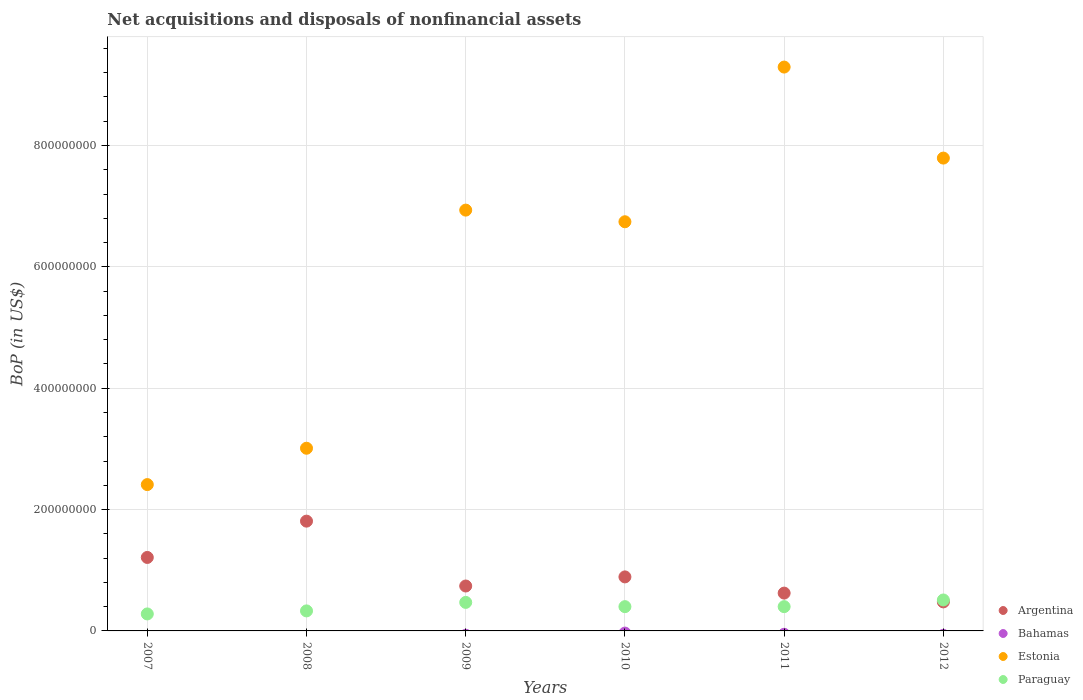How many different coloured dotlines are there?
Provide a short and direct response. 3. Is the number of dotlines equal to the number of legend labels?
Make the answer very short. No. What is the Balance of Payments in Bahamas in 2010?
Give a very brief answer. 0. Across all years, what is the maximum Balance of Payments in Estonia?
Make the answer very short. 9.29e+08. Across all years, what is the minimum Balance of Payments in Estonia?
Provide a succinct answer. 2.41e+08. In which year was the Balance of Payments in Estonia maximum?
Your answer should be very brief. 2011. What is the total Balance of Payments in Argentina in the graph?
Offer a very short reply. 5.75e+08. What is the difference between the Balance of Payments in Paraguay in 2008 and that in 2011?
Provide a short and direct response. -7.00e+06. What is the difference between the Balance of Payments in Estonia in 2011 and the Balance of Payments in Bahamas in 2008?
Ensure brevity in your answer.  9.29e+08. In the year 2011, what is the difference between the Balance of Payments in Estonia and Balance of Payments in Paraguay?
Provide a succinct answer. 8.89e+08. In how many years, is the Balance of Payments in Argentina greater than 440000000 US$?
Make the answer very short. 0. What is the ratio of the Balance of Payments in Estonia in 2007 to that in 2011?
Make the answer very short. 0.26. Is the Balance of Payments in Paraguay in 2007 less than that in 2010?
Provide a short and direct response. Yes. What is the difference between the highest and the second highest Balance of Payments in Argentina?
Keep it short and to the point. 5.98e+07. What is the difference between the highest and the lowest Balance of Payments in Argentina?
Offer a terse response. 1.33e+08. Is it the case that in every year, the sum of the Balance of Payments in Paraguay and Balance of Payments in Bahamas  is greater than the Balance of Payments in Argentina?
Give a very brief answer. No. Does the Balance of Payments in Argentina monotonically increase over the years?
Your answer should be very brief. No. How many dotlines are there?
Offer a terse response. 3. How many years are there in the graph?
Keep it short and to the point. 6. What is the difference between two consecutive major ticks on the Y-axis?
Make the answer very short. 2.00e+08. Does the graph contain grids?
Provide a succinct answer. Yes. Where does the legend appear in the graph?
Offer a terse response. Bottom right. How many legend labels are there?
Give a very brief answer. 4. How are the legend labels stacked?
Provide a succinct answer. Vertical. What is the title of the graph?
Ensure brevity in your answer.  Net acquisitions and disposals of nonfinancial assets. What is the label or title of the X-axis?
Ensure brevity in your answer.  Years. What is the label or title of the Y-axis?
Keep it short and to the point. BoP (in US$). What is the BoP (in US$) in Argentina in 2007?
Your answer should be very brief. 1.21e+08. What is the BoP (in US$) of Estonia in 2007?
Offer a very short reply. 2.41e+08. What is the BoP (in US$) in Paraguay in 2007?
Offer a terse response. 2.80e+07. What is the BoP (in US$) in Argentina in 2008?
Offer a very short reply. 1.81e+08. What is the BoP (in US$) of Estonia in 2008?
Offer a very short reply. 3.01e+08. What is the BoP (in US$) of Paraguay in 2008?
Keep it short and to the point. 3.30e+07. What is the BoP (in US$) in Argentina in 2009?
Your answer should be compact. 7.40e+07. What is the BoP (in US$) in Estonia in 2009?
Your answer should be very brief. 6.94e+08. What is the BoP (in US$) in Paraguay in 2009?
Make the answer very short. 4.70e+07. What is the BoP (in US$) in Argentina in 2010?
Provide a succinct answer. 8.90e+07. What is the BoP (in US$) of Estonia in 2010?
Your answer should be compact. 6.74e+08. What is the BoP (in US$) of Paraguay in 2010?
Make the answer very short. 4.00e+07. What is the BoP (in US$) in Argentina in 2011?
Give a very brief answer. 6.23e+07. What is the BoP (in US$) of Bahamas in 2011?
Offer a very short reply. 0. What is the BoP (in US$) in Estonia in 2011?
Offer a very short reply. 9.29e+08. What is the BoP (in US$) in Paraguay in 2011?
Your answer should be very brief. 4.00e+07. What is the BoP (in US$) of Argentina in 2012?
Offer a terse response. 4.78e+07. What is the BoP (in US$) in Estonia in 2012?
Your answer should be very brief. 7.79e+08. What is the BoP (in US$) in Paraguay in 2012?
Your response must be concise. 5.10e+07. Across all years, what is the maximum BoP (in US$) of Argentina?
Offer a terse response. 1.81e+08. Across all years, what is the maximum BoP (in US$) of Estonia?
Your answer should be compact. 9.29e+08. Across all years, what is the maximum BoP (in US$) of Paraguay?
Your answer should be compact. 5.10e+07. Across all years, what is the minimum BoP (in US$) in Argentina?
Keep it short and to the point. 4.78e+07. Across all years, what is the minimum BoP (in US$) in Estonia?
Make the answer very short. 2.41e+08. Across all years, what is the minimum BoP (in US$) of Paraguay?
Give a very brief answer. 2.80e+07. What is the total BoP (in US$) in Argentina in the graph?
Your response must be concise. 5.75e+08. What is the total BoP (in US$) of Estonia in the graph?
Your answer should be compact. 3.62e+09. What is the total BoP (in US$) in Paraguay in the graph?
Provide a short and direct response. 2.39e+08. What is the difference between the BoP (in US$) in Argentina in 2007 and that in 2008?
Offer a terse response. -5.98e+07. What is the difference between the BoP (in US$) in Estonia in 2007 and that in 2008?
Provide a short and direct response. -5.99e+07. What is the difference between the BoP (in US$) of Paraguay in 2007 and that in 2008?
Your response must be concise. -5.00e+06. What is the difference between the BoP (in US$) of Argentina in 2007 and that in 2009?
Provide a succinct answer. 4.71e+07. What is the difference between the BoP (in US$) of Estonia in 2007 and that in 2009?
Provide a succinct answer. -4.52e+08. What is the difference between the BoP (in US$) of Paraguay in 2007 and that in 2009?
Offer a terse response. -1.90e+07. What is the difference between the BoP (in US$) in Argentina in 2007 and that in 2010?
Ensure brevity in your answer.  3.21e+07. What is the difference between the BoP (in US$) of Estonia in 2007 and that in 2010?
Give a very brief answer. -4.33e+08. What is the difference between the BoP (in US$) of Paraguay in 2007 and that in 2010?
Offer a terse response. -1.20e+07. What is the difference between the BoP (in US$) of Argentina in 2007 and that in 2011?
Your answer should be very brief. 5.88e+07. What is the difference between the BoP (in US$) of Estonia in 2007 and that in 2011?
Ensure brevity in your answer.  -6.88e+08. What is the difference between the BoP (in US$) in Paraguay in 2007 and that in 2011?
Ensure brevity in your answer.  -1.20e+07. What is the difference between the BoP (in US$) of Argentina in 2007 and that in 2012?
Your response must be concise. 7.33e+07. What is the difference between the BoP (in US$) in Estonia in 2007 and that in 2012?
Offer a terse response. -5.38e+08. What is the difference between the BoP (in US$) of Paraguay in 2007 and that in 2012?
Your response must be concise. -2.30e+07. What is the difference between the BoP (in US$) of Argentina in 2008 and that in 2009?
Ensure brevity in your answer.  1.07e+08. What is the difference between the BoP (in US$) in Estonia in 2008 and that in 2009?
Offer a terse response. -3.92e+08. What is the difference between the BoP (in US$) in Paraguay in 2008 and that in 2009?
Offer a terse response. -1.40e+07. What is the difference between the BoP (in US$) of Argentina in 2008 and that in 2010?
Give a very brief answer. 9.19e+07. What is the difference between the BoP (in US$) of Estonia in 2008 and that in 2010?
Offer a very short reply. -3.73e+08. What is the difference between the BoP (in US$) of Paraguay in 2008 and that in 2010?
Offer a very short reply. -7.00e+06. What is the difference between the BoP (in US$) of Argentina in 2008 and that in 2011?
Keep it short and to the point. 1.19e+08. What is the difference between the BoP (in US$) of Estonia in 2008 and that in 2011?
Offer a very short reply. -6.28e+08. What is the difference between the BoP (in US$) of Paraguay in 2008 and that in 2011?
Make the answer very short. -7.00e+06. What is the difference between the BoP (in US$) of Argentina in 2008 and that in 2012?
Offer a very short reply. 1.33e+08. What is the difference between the BoP (in US$) in Estonia in 2008 and that in 2012?
Your answer should be very brief. -4.78e+08. What is the difference between the BoP (in US$) of Paraguay in 2008 and that in 2012?
Offer a terse response. -1.80e+07. What is the difference between the BoP (in US$) of Argentina in 2009 and that in 2010?
Keep it short and to the point. -1.50e+07. What is the difference between the BoP (in US$) in Estonia in 2009 and that in 2010?
Your response must be concise. 1.92e+07. What is the difference between the BoP (in US$) of Paraguay in 2009 and that in 2010?
Offer a very short reply. 7.00e+06. What is the difference between the BoP (in US$) in Argentina in 2009 and that in 2011?
Your response must be concise. 1.17e+07. What is the difference between the BoP (in US$) in Estonia in 2009 and that in 2011?
Make the answer very short. -2.36e+08. What is the difference between the BoP (in US$) of Paraguay in 2009 and that in 2011?
Offer a very short reply. 7.00e+06. What is the difference between the BoP (in US$) of Argentina in 2009 and that in 2012?
Provide a succinct answer. 2.62e+07. What is the difference between the BoP (in US$) in Estonia in 2009 and that in 2012?
Give a very brief answer. -8.58e+07. What is the difference between the BoP (in US$) in Paraguay in 2009 and that in 2012?
Make the answer very short. -4.00e+06. What is the difference between the BoP (in US$) of Argentina in 2010 and that in 2011?
Make the answer very short. 2.67e+07. What is the difference between the BoP (in US$) of Estonia in 2010 and that in 2011?
Keep it short and to the point. -2.55e+08. What is the difference between the BoP (in US$) in Paraguay in 2010 and that in 2011?
Provide a succinct answer. 0. What is the difference between the BoP (in US$) of Argentina in 2010 and that in 2012?
Your answer should be very brief. 4.12e+07. What is the difference between the BoP (in US$) in Estonia in 2010 and that in 2012?
Ensure brevity in your answer.  -1.05e+08. What is the difference between the BoP (in US$) in Paraguay in 2010 and that in 2012?
Your response must be concise. -1.10e+07. What is the difference between the BoP (in US$) of Argentina in 2011 and that in 2012?
Your answer should be very brief. 1.45e+07. What is the difference between the BoP (in US$) in Estonia in 2011 and that in 2012?
Make the answer very short. 1.50e+08. What is the difference between the BoP (in US$) in Paraguay in 2011 and that in 2012?
Your response must be concise. -1.10e+07. What is the difference between the BoP (in US$) of Argentina in 2007 and the BoP (in US$) of Estonia in 2008?
Make the answer very short. -1.80e+08. What is the difference between the BoP (in US$) of Argentina in 2007 and the BoP (in US$) of Paraguay in 2008?
Provide a succinct answer. 8.81e+07. What is the difference between the BoP (in US$) of Estonia in 2007 and the BoP (in US$) of Paraguay in 2008?
Your answer should be very brief. 2.08e+08. What is the difference between the BoP (in US$) in Argentina in 2007 and the BoP (in US$) in Estonia in 2009?
Your response must be concise. -5.72e+08. What is the difference between the BoP (in US$) in Argentina in 2007 and the BoP (in US$) in Paraguay in 2009?
Keep it short and to the point. 7.41e+07. What is the difference between the BoP (in US$) of Estonia in 2007 and the BoP (in US$) of Paraguay in 2009?
Your response must be concise. 1.94e+08. What is the difference between the BoP (in US$) in Argentina in 2007 and the BoP (in US$) in Estonia in 2010?
Offer a very short reply. -5.53e+08. What is the difference between the BoP (in US$) of Argentina in 2007 and the BoP (in US$) of Paraguay in 2010?
Ensure brevity in your answer.  8.11e+07. What is the difference between the BoP (in US$) of Estonia in 2007 and the BoP (in US$) of Paraguay in 2010?
Provide a short and direct response. 2.01e+08. What is the difference between the BoP (in US$) in Argentina in 2007 and the BoP (in US$) in Estonia in 2011?
Ensure brevity in your answer.  -8.08e+08. What is the difference between the BoP (in US$) of Argentina in 2007 and the BoP (in US$) of Paraguay in 2011?
Your answer should be very brief. 8.11e+07. What is the difference between the BoP (in US$) in Estonia in 2007 and the BoP (in US$) in Paraguay in 2011?
Your response must be concise. 2.01e+08. What is the difference between the BoP (in US$) in Argentina in 2007 and the BoP (in US$) in Estonia in 2012?
Provide a succinct answer. -6.58e+08. What is the difference between the BoP (in US$) in Argentina in 2007 and the BoP (in US$) in Paraguay in 2012?
Offer a very short reply. 7.01e+07. What is the difference between the BoP (in US$) of Estonia in 2007 and the BoP (in US$) of Paraguay in 2012?
Keep it short and to the point. 1.90e+08. What is the difference between the BoP (in US$) in Argentina in 2008 and the BoP (in US$) in Estonia in 2009?
Provide a succinct answer. -5.13e+08. What is the difference between the BoP (in US$) of Argentina in 2008 and the BoP (in US$) of Paraguay in 2009?
Offer a terse response. 1.34e+08. What is the difference between the BoP (in US$) of Estonia in 2008 and the BoP (in US$) of Paraguay in 2009?
Provide a succinct answer. 2.54e+08. What is the difference between the BoP (in US$) of Argentina in 2008 and the BoP (in US$) of Estonia in 2010?
Your answer should be compact. -4.93e+08. What is the difference between the BoP (in US$) in Argentina in 2008 and the BoP (in US$) in Paraguay in 2010?
Give a very brief answer. 1.41e+08. What is the difference between the BoP (in US$) in Estonia in 2008 and the BoP (in US$) in Paraguay in 2010?
Offer a terse response. 2.61e+08. What is the difference between the BoP (in US$) of Argentina in 2008 and the BoP (in US$) of Estonia in 2011?
Give a very brief answer. -7.48e+08. What is the difference between the BoP (in US$) in Argentina in 2008 and the BoP (in US$) in Paraguay in 2011?
Give a very brief answer. 1.41e+08. What is the difference between the BoP (in US$) of Estonia in 2008 and the BoP (in US$) of Paraguay in 2011?
Ensure brevity in your answer.  2.61e+08. What is the difference between the BoP (in US$) of Argentina in 2008 and the BoP (in US$) of Estonia in 2012?
Offer a terse response. -5.98e+08. What is the difference between the BoP (in US$) of Argentina in 2008 and the BoP (in US$) of Paraguay in 2012?
Provide a succinct answer. 1.30e+08. What is the difference between the BoP (in US$) in Estonia in 2008 and the BoP (in US$) in Paraguay in 2012?
Your answer should be very brief. 2.50e+08. What is the difference between the BoP (in US$) of Argentina in 2009 and the BoP (in US$) of Estonia in 2010?
Keep it short and to the point. -6.00e+08. What is the difference between the BoP (in US$) of Argentina in 2009 and the BoP (in US$) of Paraguay in 2010?
Keep it short and to the point. 3.40e+07. What is the difference between the BoP (in US$) of Estonia in 2009 and the BoP (in US$) of Paraguay in 2010?
Provide a succinct answer. 6.54e+08. What is the difference between the BoP (in US$) in Argentina in 2009 and the BoP (in US$) in Estonia in 2011?
Offer a very short reply. -8.55e+08. What is the difference between the BoP (in US$) in Argentina in 2009 and the BoP (in US$) in Paraguay in 2011?
Your response must be concise. 3.40e+07. What is the difference between the BoP (in US$) in Estonia in 2009 and the BoP (in US$) in Paraguay in 2011?
Your answer should be very brief. 6.54e+08. What is the difference between the BoP (in US$) in Argentina in 2009 and the BoP (in US$) in Estonia in 2012?
Your answer should be compact. -7.05e+08. What is the difference between the BoP (in US$) in Argentina in 2009 and the BoP (in US$) in Paraguay in 2012?
Provide a short and direct response. 2.30e+07. What is the difference between the BoP (in US$) of Estonia in 2009 and the BoP (in US$) of Paraguay in 2012?
Make the answer very short. 6.43e+08. What is the difference between the BoP (in US$) of Argentina in 2010 and the BoP (in US$) of Estonia in 2011?
Your response must be concise. -8.40e+08. What is the difference between the BoP (in US$) of Argentina in 2010 and the BoP (in US$) of Paraguay in 2011?
Provide a succinct answer. 4.90e+07. What is the difference between the BoP (in US$) in Estonia in 2010 and the BoP (in US$) in Paraguay in 2011?
Provide a succinct answer. 6.34e+08. What is the difference between the BoP (in US$) of Argentina in 2010 and the BoP (in US$) of Estonia in 2012?
Ensure brevity in your answer.  -6.90e+08. What is the difference between the BoP (in US$) in Argentina in 2010 and the BoP (in US$) in Paraguay in 2012?
Offer a terse response. 3.80e+07. What is the difference between the BoP (in US$) of Estonia in 2010 and the BoP (in US$) of Paraguay in 2012?
Your answer should be compact. 6.23e+08. What is the difference between the BoP (in US$) in Argentina in 2011 and the BoP (in US$) in Estonia in 2012?
Your response must be concise. -7.17e+08. What is the difference between the BoP (in US$) of Argentina in 2011 and the BoP (in US$) of Paraguay in 2012?
Your response must be concise. 1.13e+07. What is the difference between the BoP (in US$) in Estonia in 2011 and the BoP (in US$) in Paraguay in 2012?
Ensure brevity in your answer.  8.78e+08. What is the average BoP (in US$) in Argentina per year?
Provide a short and direct response. 9.59e+07. What is the average BoP (in US$) of Bahamas per year?
Your response must be concise. 0. What is the average BoP (in US$) of Estonia per year?
Your answer should be compact. 6.03e+08. What is the average BoP (in US$) of Paraguay per year?
Make the answer very short. 3.98e+07. In the year 2007, what is the difference between the BoP (in US$) in Argentina and BoP (in US$) in Estonia?
Make the answer very short. -1.20e+08. In the year 2007, what is the difference between the BoP (in US$) in Argentina and BoP (in US$) in Paraguay?
Provide a succinct answer. 9.31e+07. In the year 2007, what is the difference between the BoP (in US$) of Estonia and BoP (in US$) of Paraguay?
Your response must be concise. 2.13e+08. In the year 2008, what is the difference between the BoP (in US$) in Argentina and BoP (in US$) in Estonia?
Your response must be concise. -1.20e+08. In the year 2008, what is the difference between the BoP (in US$) of Argentina and BoP (in US$) of Paraguay?
Provide a short and direct response. 1.48e+08. In the year 2008, what is the difference between the BoP (in US$) of Estonia and BoP (in US$) of Paraguay?
Offer a terse response. 2.68e+08. In the year 2009, what is the difference between the BoP (in US$) in Argentina and BoP (in US$) in Estonia?
Provide a succinct answer. -6.19e+08. In the year 2009, what is the difference between the BoP (in US$) in Argentina and BoP (in US$) in Paraguay?
Your response must be concise. 2.70e+07. In the year 2009, what is the difference between the BoP (in US$) of Estonia and BoP (in US$) of Paraguay?
Your answer should be very brief. 6.47e+08. In the year 2010, what is the difference between the BoP (in US$) in Argentina and BoP (in US$) in Estonia?
Keep it short and to the point. -5.85e+08. In the year 2010, what is the difference between the BoP (in US$) of Argentina and BoP (in US$) of Paraguay?
Ensure brevity in your answer.  4.90e+07. In the year 2010, what is the difference between the BoP (in US$) in Estonia and BoP (in US$) in Paraguay?
Your answer should be very brief. 6.34e+08. In the year 2011, what is the difference between the BoP (in US$) in Argentina and BoP (in US$) in Estonia?
Your answer should be compact. -8.67e+08. In the year 2011, what is the difference between the BoP (in US$) of Argentina and BoP (in US$) of Paraguay?
Provide a succinct answer. 2.23e+07. In the year 2011, what is the difference between the BoP (in US$) of Estonia and BoP (in US$) of Paraguay?
Your answer should be very brief. 8.89e+08. In the year 2012, what is the difference between the BoP (in US$) of Argentina and BoP (in US$) of Estonia?
Your answer should be compact. -7.31e+08. In the year 2012, what is the difference between the BoP (in US$) in Argentina and BoP (in US$) in Paraguay?
Offer a terse response. -3.16e+06. In the year 2012, what is the difference between the BoP (in US$) of Estonia and BoP (in US$) of Paraguay?
Keep it short and to the point. 7.28e+08. What is the ratio of the BoP (in US$) of Argentina in 2007 to that in 2008?
Make the answer very short. 0.67. What is the ratio of the BoP (in US$) of Estonia in 2007 to that in 2008?
Give a very brief answer. 0.8. What is the ratio of the BoP (in US$) in Paraguay in 2007 to that in 2008?
Give a very brief answer. 0.85. What is the ratio of the BoP (in US$) of Argentina in 2007 to that in 2009?
Provide a short and direct response. 1.64. What is the ratio of the BoP (in US$) of Estonia in 2007 to that in 2009?
Provide a succinct answer. 0.35. What is the ratio of the BoP (in US$) of Paraguay in 2007 to that in 2009?
Your answer should be very brief. 0.6. What is the ratio of the BoP (in US$) in Argentina in 2007 to that in 2010?
Keep it short and to the point. 1.36. What is the ratio of the BoP (in US$) in Estonia in 2007 to that in 2010?
Ensure brevity in your answer.  0.36. What is the ratio of the BoP (in US$) in Argentina in 2007 to that in 2011?
Your response must be concise. 1.94. What is the ratio of the BoP (in US$) of Estonia in 2007 to that in 2011?
Provide a short and direct response. 0.26. What is the ratio of the BoP (in US$) in Paraguay in 2007 to that in 2011?
Your response must be concise. 0.7. What is the ratio of the BoP (in US$) of Argentina in 2007 to that in 2012?
Your answer should be very brief. 2.53. What is the ratio of the BoP (in US$) of Estonia in 2007 to that in 2012?
Make the answer very short. 0.31. What is the ratio of the BoP (in US$) in Paraguay in 2007 to that in 2012?
Your answer should be compact. 0.55. What is the ratio of the BoP (in US$) of Argentina in 2008 to that in 2009?
Offer a very short reply. 2.44. What is the ratio of the BoP (in US$) in Estonia in 2008 to that in 2009?
Keep it short and to the point. 0.43. What is the ratio of the BoP (in US$) of Paraguay in 2008 to that in 2009?
Give a very brief answer. 0.7. What is the ratio of the BoP (in US$) in Argentina in 2008 to that in 2010?
Give a very brief answer. 2.03. What is the ratio of the BoP (in US$) in Estonia in 2008 to that in 2010?
Provide a short and direct response. 0.45. What is the ratio of the BoP (in US$) in Paraguay in 2008 to that in 2010?
Make the answer very short. 0.82. What is the ratio of the BoP (in US$) of Argentina in 2008 to that in 2011?
Provide a short and direct response. 2.9. What is the ratio of the BoP (in US$) of Estonia in 2008 to that in 2011?
Your answer should be compact. 0.32. What is the ratio of the BoP (in US$) of Paraguay in 2008 to that in 2011?
Ensure brevity in your answer.  0.82. What is the ratio of the BoP (in US$) in Argentina in 2008 to that in 2012?
Your answer should be compact. 3.78. What is the ratio of the BoP (in US$) in Estonia in 2008 to that in 2012?
Ensure brevity in your answer.  0.39. What is the ratio of the BoP (in US$) of Paraguay in 2008 to that in 2012?
Offer a terse response. 0.65. What is the ratio of the BoP (in US$) in Argentina in 2009 to that in 2010?
Provide a short and direct response. 0.83. What is the ratio of the BoP (in US$) in Estonia in 2009 to that in 2010?
Provide a succinct answer. 1.03. What is the ratio of the BoP (in US$) of Paraguay in 2009 to that in 2010?
Make the answer very short. 1.18. What is the ratio of the BoP (in US$) of Argentina in 2009 to that in 2011?
Offer a terse response. 1.19. What is the ratio of the BoP (in US$) of Estonia in 2009 to that in 2011?
Offer a very short reply. 0.75. What is the ratio of the BoP (in US$) of Paraguay in 2009 to that in 2011?
Ensure brevity in your answer.  1.18. What is the ratio of the BoP (in US$) of Argentina in 2009 to that in 2012?
Give a very brief answer. 1.55. What is the ratio of the BoP (in US$) in Estonia in 2009 to that in 2012?
Keep it short and to the point. 0.89. What is the ratio of the BoP (in US$) of Paraguay in 2009 to that in 2012?
Offer a very short reply. 0.92. What is the ratio of the BoP (in US$) in Argentina in 2010 to that in 2011?
Offer a terse response. 1.43. What is the ratio of the BoP (in US$) in Estonia in 2010 to that in 2011?
Keep it short and to the point. 0.73. What is the ratio of the BoP (in US$) in Paraguay in 2010 to that in 2011?
Make the answer very short. 1. What is the ratio of the BoP (in US$) of Argentina in 2010 to that in 2012?
Make the answer very short. 1.86. What is the ratio of the BoP (in US$) of Estonia in 2010 to that in 2012?
Provide a short and direct response. 0.87. What is the ratio of the BoP (in US$) in Paraguay in 2010 to that in 2012?
Provide a succinct answer. 0.78. What is the ratio of the BoP (in US$) of Argentina in 2011 to that in 2012?
Make the answer very short. 1.3. What is the ratio of the BoP (in US$) in Estonia in 2011 to that in 2012?
Provide a short and direct response. 1.19. What is the ratio of the BoP (in US$) in Paraguay in 2011 to that in 2012?
Ensure brevity in your answer.  0.78. What is the difference between the highest and the second highest BoP (in US$) of Argentina?
Make the answer very short. 5.98e+07. What is the difference between the highest and the second highest BoP (in US$) in Estonia?
Your response must be concise. 1.50e+08. What is the difference between the highest and the second highest BoP (in US$) in Paraguay?
Your answer should be very brief. 4.00e+06. What is the difference between the highest and the lowest BoP (in US$) in Argentina?
Keep it short and to the point. 1.33e+08. What is the difference between the highest and the lowest BoP (in US$) of Estonia?
Provide a succinct answer. 6.88e+08. What is the difference between the highest and the lowest BoP (in US$) in Paraguay?
Offer a very short reply. 2.30e+07. 